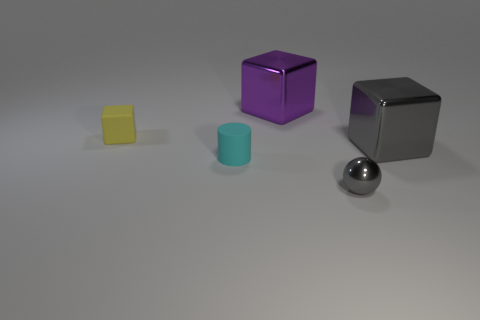Is there any other thing that is the same shape as the tiny cyan rubber object?
Make the answer very short. No. Are there any large purple metallic things of the same shape as the tiny yellow matte thing?
Your response must be concise. Yes. What number of blue shiny blocks are there?
Give a very brief answer. 0. What shape is the purple shiny thing?
Offer a terse response. Cube. What number of cyan rubber objects have the same size as the rubber cube?
Ensure brevity in your answer.  1. Is the shape of the tiny yellow object the same as the large purple object?
Give a very brief answer. Yes. What is the color of the big cube on the right side of the large block that is behind the gray metal cube?
Keep it short and to the point. Gray. There is a metal thing that is both to the left of the gray shiny cube and behind the tiny metal sphere; what is its size?
Your answer should be compact. Large. Is there anything else that is the same color as the metallic ball?
Offer a very short reply. Yes. There is a object that is the same material as the cylinder; what is its shape?
Your answer should be very brief. Cube. 